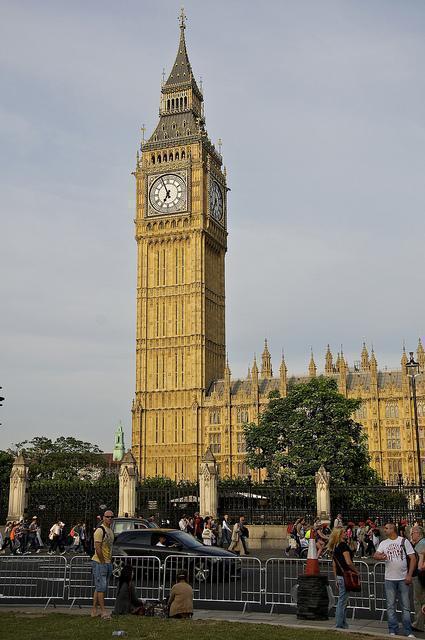The clock is reading five minutes before which hour?
Indicate the correct response by choosing from the four available options to answer the question.
Options: Eleven, twelve, seven, eight. Seven. 